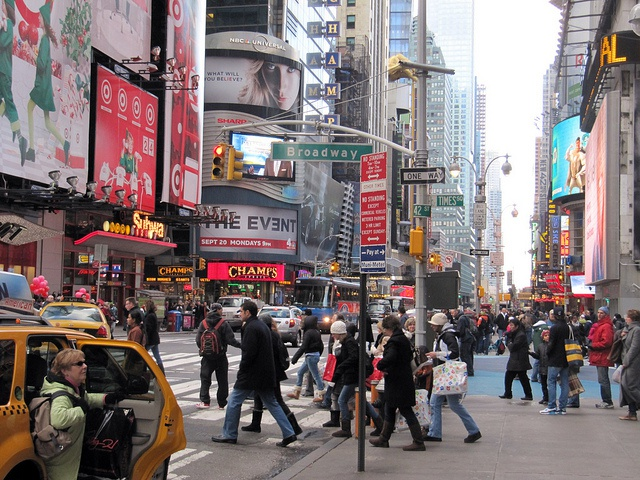Describe the objects in this image and their specific colors. I can see people in darkgray, black, gray, and maroon tones, car in darkgray, black, brown, maroon, and gray tones, people in darkgray, black, gray, and darkblue tones, people in darkgray, black, and gray tones, and people in darkgray, black, gray, and lightgray tones in this image. 